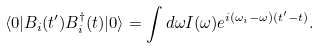Convert formula to latex. <formula><loc_0><loc_0><loc_500><loc_500>\langle 0 | B _ { i } ( t ^ { \prime } ) B _ { i } ^ { \dagger } ( t ) | 0 \rangle = \int d \omega I ( \omega ) e ^ { i ( \omega _ { i } - \omega ) ( t ^ { \prime } - t ) } .</formula> 